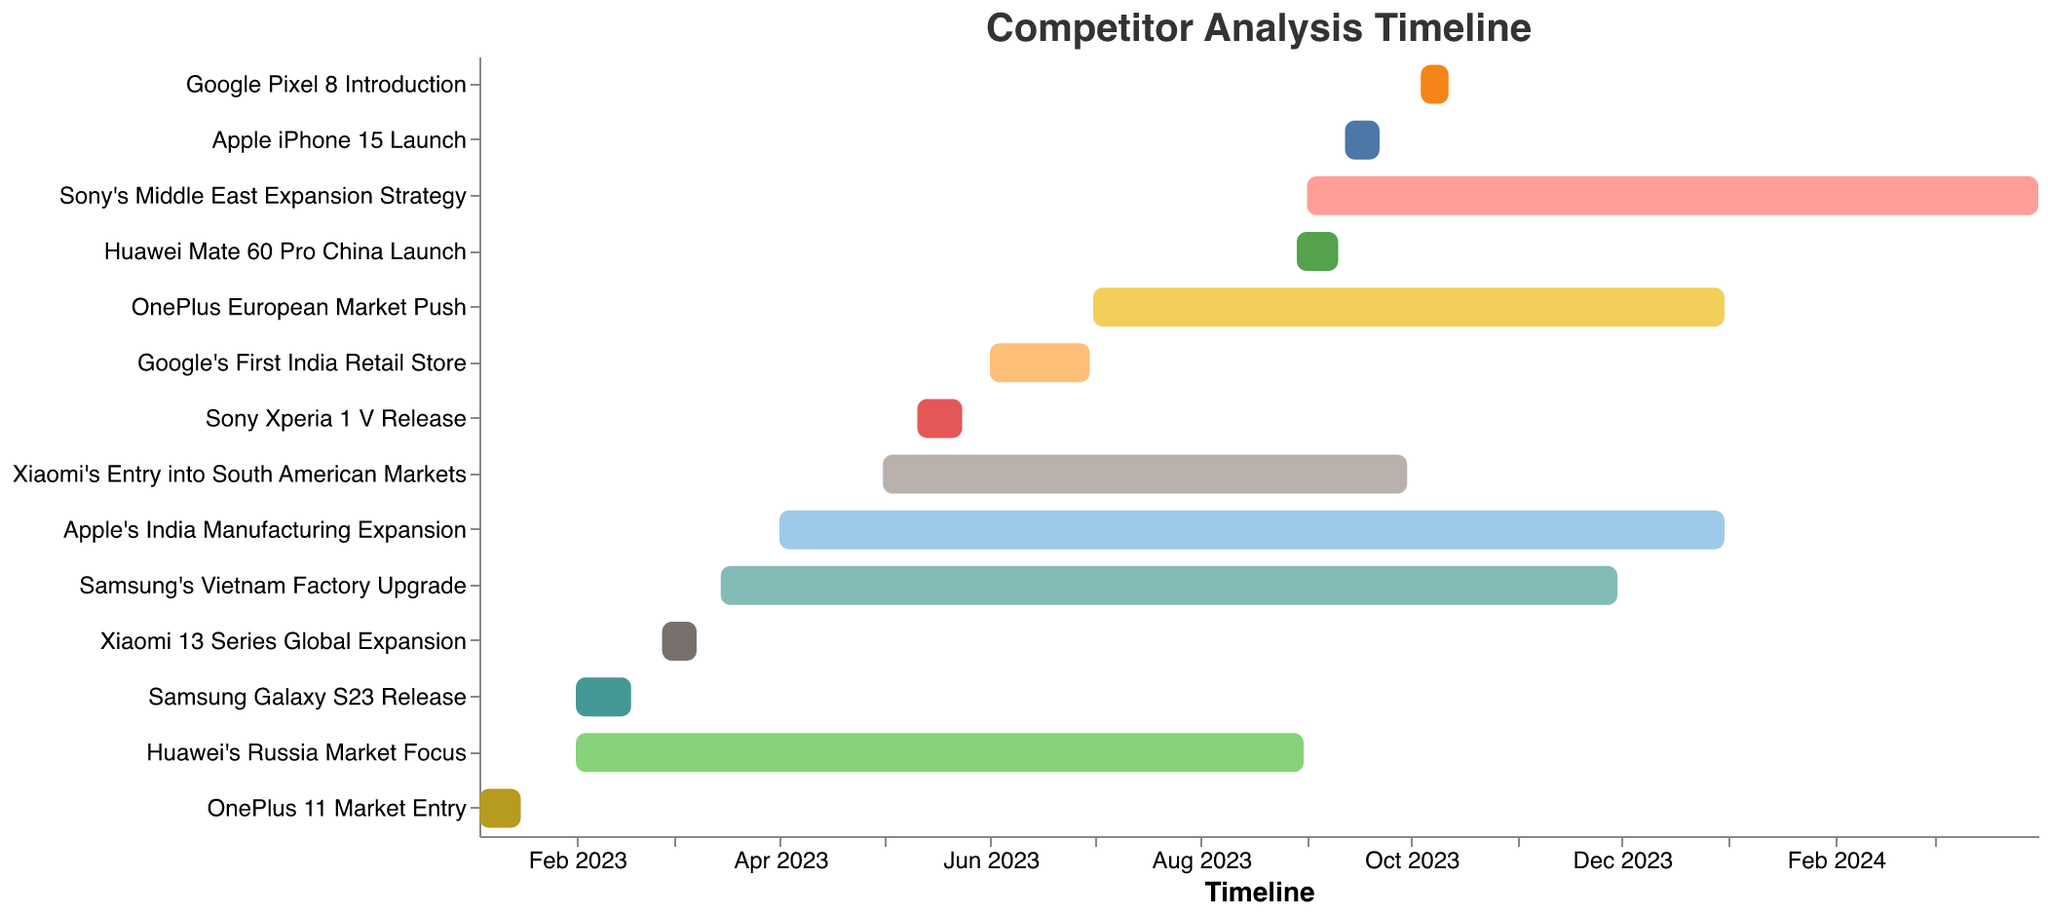When did the Google Pixel 8 Introduction happen? Locate the task named "Google Pixel 8 Introduction" on the Y-axis and check its corresponding start and end dates on the X-axis.
Answer: 2023-10-04 to 2023-10-12 How long was the Apple iPhone 15 Launch? Find the Apple iPhone 15 Launch task, note the start (2023-09-12) and end (2023-09-22) dates, and calculate the duration by subtracting the start date from the end date.
Answer: 10 days Which event happened in the earliest quarter of 2023? Identify tasks occurring in the first quarter by checking their start dates, then find the earliest among them.
Answer: OnePlus 11 Market Entry Which task had the longest duration? Compare the durations of all tasks by calculating the difference between their start and end dates, then find the one with the maximum duration.
Answer: Apple's India Manufacturing Expansion and OnePlus European Market Push (9 months, 31 days each) How many tasks were completed before June 2023? Count the tasks whose end dates are before June 1, 2023.
Answer: 5 tasks Did Sony Xperia 1 V Release and Google's First India Retail Store overlap in their timelines? Check the timeline of both tasks and see if their date ranges intersect.
Answer: No Which company had the most product releases in 2023? Count the number of product release events by each company using the task names and identify the company with the highest count.
Answer: Xiaomi and Huawei (both had 2 releases) What was the timeframe of Huawei's Russia Market Focus? Locate the task "Huawei's Russia Market Focus" on the Y-axis and check its corresponding start and end dates.
Answer: 2023-02-01 to 2023-08-31 Which regional market push was slated to complete by the end of December 2023? Identify tasks related to market pushes and look for those ending by December 31, 2023.
Answer: OnePlus European Market Push How many companies had tasks spanning multiple quarters? Determine which tasks span across at least two different quarters by checking the start and end dates.
Answer: 5 companies (Apple, Samsung, Xiaomi, OnePlus, and Sony) 